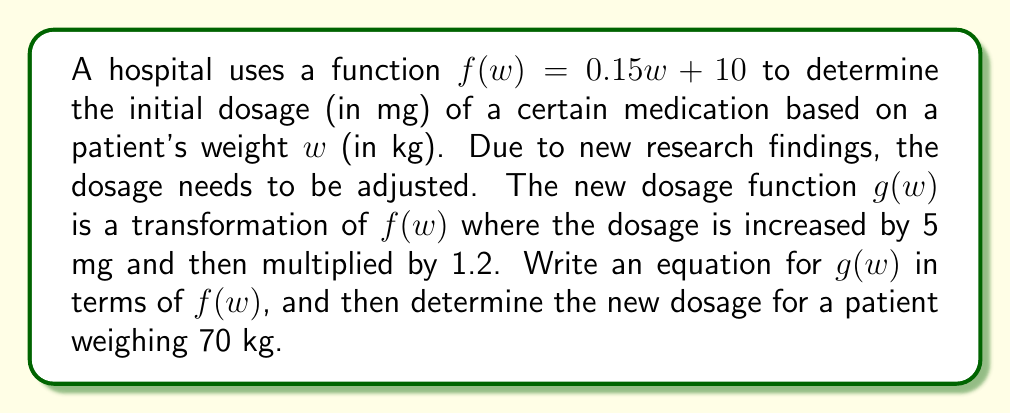Help me with this question. To solve this problem, we'll follow these steps:

1) First, let's understand the transformations applied to $f(w)$:
   - The dosage is increased by 5 mg
   - The result is then multiplied by 1.2

2) We can represent these transformations mathematically as:
   $g(w) = 1.2(f(w) + 5)$

3) This is because we first add 5 to $f(w)$, and then multiply the result by 1.2.

4) Now that we have $g(w)$ in terms of $f(w)$, let's calculate the new dosage for a 70 kg patient:

   $g(70) = 1.2(f(70) + 5)$

5) To solve this, we first need to calculate $f(70)$:
   $f(70) = 0.15(70) + 10 = 10.5 + 10 = 20.5$ mg

6) Now we can substitute this back into our equation for $g(70)$:
   $g(70) = 1.2(20.5 + 5) = 1.2(25.5) = 30.6$ mg

Therefore, the new dosage for a 70 kg patient would be 30.6 mg.
Answer: $g(w) = 1.2(f(w) + 5)$
New dosage for a 70 kg patient: 30.6 mg 